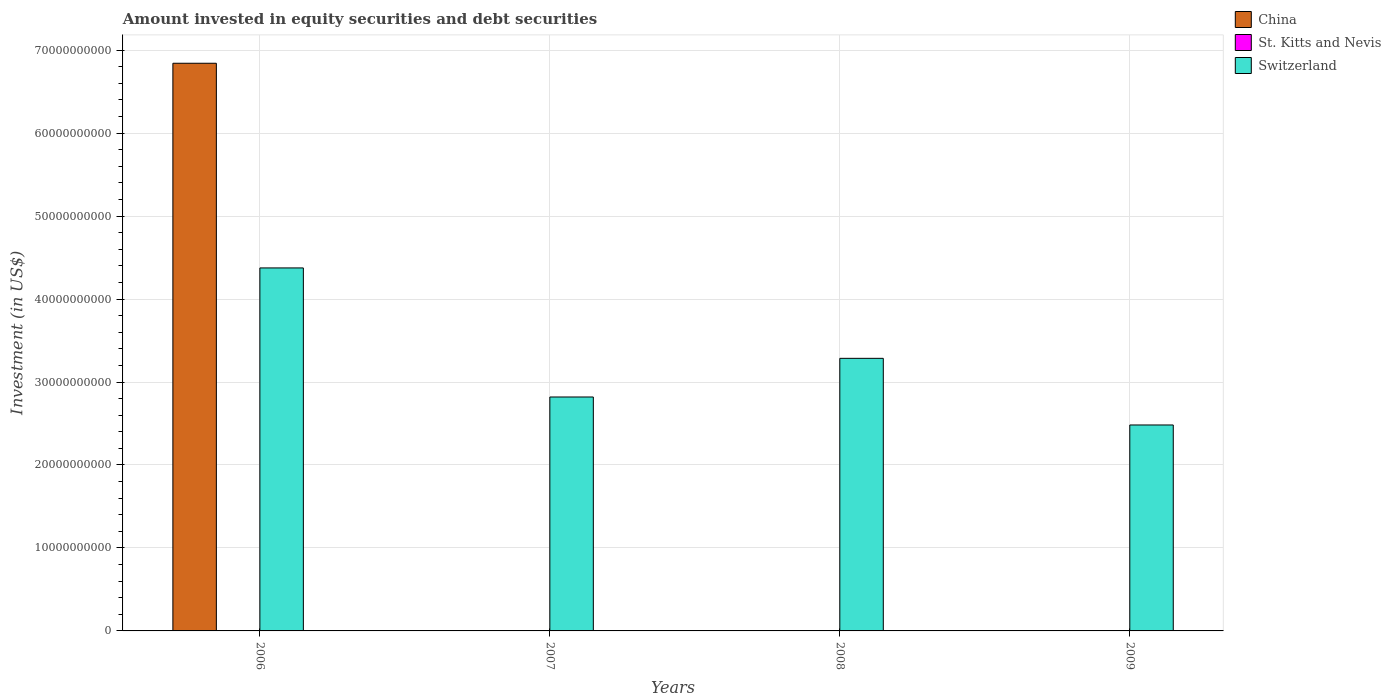How many different coloured bars are there?
Keep it short and to the point. 3. In how many cases, is the number of bars for a given year not equal to the number of legend labels?
Your answer should be very brief. 3. Across all years, what is the maximum amount invested in equity securities and debt securities in China?
Provide a succinct answer. 6.84e+1. In which year was the amount invested in equity securities and debt securities in Switzerland maximum?
Ensure brevity in your answer.  2006. What is the total amount invested in equity securities and debt securities in China in the graph?
Ensure brevity in your answer.  6.84e+1. What is the difference between the amount invested in equity securities and debt securities in Switzerland in 2006 and that in 2008?
Your answer should be compact. 1.09e+1. What is the difference between the amount invested in equity securities and debt securities in St. Kitts and Nevis in 2007 and the amount invested in equity securities and debt securities in China in 2009?
Your answer should be compact. 1.30e+07. What is the average amount invested in equity securities and debt securities in China per year?
Offer a terse response. 1.71e+1. In the year 2006, what is the difference between the amount invested in equity securities and debt securities in St. Kitts and Nevis and amount invested in equity securities and debt securities in Switzerland?
Provide a succinct answer. -4.37e+1. In how many years, is the amount invested in equity securities and debt securities in St. Kitts and Nevis greater than 68000000000 US$?
Ensure brevity in your answer.  0. What is the ratio of the amount invested in equity securities and debt securities in Switzerland in 2006 to that in 2008?
Provide a succinct answer. 1.33. Is the amount invested in equity securities and debt securities in Switzerland in 2008 less than that in 2009?
Offer a terse response. No. Is the difference between the amount invested in equity securities and debt securities in St. Kitts and Nevis in 2006 and 2009 greater than the difference between the amount invested in equity securities and debt securities in Switzerland in 2006 and 2009?
Offer a terse response. No. What is the difference between the highest and the second highest amount invested in equity securities and debt securities in St. Kitts and Nevis?
Keep it short and to the point. 7.99e+06. What is the difference between the highest and the lowest amount invested in equity securities and debt securities in St. Kitts and Nevis?
Provide a short and direct response. 2.10e+07. How many years are there in the graph?
Keep it short and to the point. 4. What is the difference between two consecutive major ticks on the Y-axis?
Provide a succinct answer. 1.00e+1. Are the values on the major ticks of Y-axis written in scientific E-notation?
Make the answer very short. No. Does the graph contain grids?
Your response must be concise. Yes. Where does the legend appear in the graph?
Give a very brief answer. Top right. How many legend labels are there?
Keep it short and to the point. 3. How are the legend labels stacked?
Provide a succinct answer. Vertical. What is the title of the graph?
Your response must be concise. Amount invested in equity securities and debt securities. Does "High income" appear as one of the legend labels in the graph?
Ensure brevity in your answer.  No. What is the label or title of the Y-axis?
Give a very brief answer. Investment (in US$). What is the Investment (in US$) of China in 2006?
Offer a very short reply. 6.84e+1. What is the Investment (in US$) of St. Kitts and Nevis in 2006?
Ensure brevity in your answer.  2.10e+07. What is the Investment (in US$) of Switzerland in 2006?
Your answer should be very brief. 4.37e+1. What is the Investment (in US$) of China in 2007?
Keep it short and to the point. 0. What is the Investment (in US$) of St. Kitts and Nevis in 2007?
Offer a terse response. 1.30e+07. What is the Investment (in US$) of Switzerland in 2007?
Your answer should be very brief. 2.82e+1. What is the Investment (in US$) of China in 2008?
Make the answer very short. 0. What is the Investment (in US$) of St. Kitts and Nevis in 2008?
Give a very brief answer. 0. What is the Investment (in US$) of Switzerland in 2008?
Provide a short and direct response. 3.29e+1. What is the Investment (in US$) of China in 2009?
Offer a terse response. 0. What is the Investment (in US$) in St. Kitts and Nevis in 2009?
Your answer should be compact. 1.12e+07. What is the Investment (in US$) in Switzerland in 2009?
Your answer should be very brief. 2.48e+1. Across all years, what is the maximum Investment (in US$) of China?
Your response must be concise. 6.84e+1. Across all years, what is the maximum Investment (in US$) of St. Kitts and Nevis?
Your response must be concise. 2.10e+07. Across all years, what is the maximum Investment (in US$) in Switzerland?
Provide a succinct answer. 4.37e+1. Across all years, what is the minimum Investment (in US$) in St. Kitts and Nevis?
Offer a very short reply. 0. Across all years, what is the minimum Investment (in US$) in Switzerland?
Offer a very short reply. 2.48e+1. What is the total Investment (in US$) of China in the graph?
Keep it short and to the point. 6.84e+1. What is the total Investment (in US$) in St. Kitts and Nevis in the graph?
Offer a terse response. 4.51e+07. What is the total Investment (in US$) in Switzerland in the graph?
Your answer should be compact. 1.30e+11. What is the difference between the Investment (in US$) in St. Kitts and Nevis in 2006 and that in 2007?
Ensure brevity in your answer.  7.99e+06. What is the difference between the Investment (in US$) in Switzerland in 2006 and that in 2007?
Provide a short and direct response. 1.56e+1. What is the difference between the Investment (in US$) in Switzerland in 2006 and that in 2008?
Keep it short and to the point. 1.09e+1. What is the difference between the Investment (in US$) of St. Kitts and Nevis in 2006 and that in 2009?
Provide a short and direct response. 9.81e+06. What is the difference between the Investment (in US$) in Switzerland in 2006 and that in 2009?
Your answer should be very brief. 1.89e+1. What is the difference between the Investment (in US$) in Switzerland in 2007 and that in 2008?
Your answer should be compact. -4.66e+09. What is the difference between the Investment (in US$) of St. Kitts and Nevis in 2007 and that in 2009?
Your response must be concise. 1.82e+06. What is the difference between the Investment (in US$) in Switzerland in 2007 and that in 2009?
Your answer should be very brief. 3.37e+09. What is the difference between the Investment (in US$) of Switzerland in 2008 and that in 2009?
Your answer should be very brief. 8.03e+09. What is the difference between the Investment (in US$) in China in 2006 and the Investment (in US$) in St. Kitts and Nevis in 2007?
Offer a very short reply. 6.84e+1. What is the difference between the Investment (in US$) in China in 2006 and the Investment (in US$) in Switzerland in 2007?
Keep it short and to the point. 4.02e+1. What is the difference between the Investment (in US$) in St. Kitts and Nevis in 2006 and the Investment (in US$) in Switzerland in 2007?
Make the answer very short. -2.82e+1. What is the difference between the Investment (in US$) in China in 2006 and the Investment (in US$) in Switzerland in 2008?
Offer a very short reply. 3.56e+1. What is the difference between the Investment (in US$) in St. Kitts and Nevis in 2006 and the Investment (in US$) in Switzerland in 2008?
Your answer should be very brief. -3.28e+1. What is the difference between the Investment (in US$) of China in 2006 and the Investment (in US$) of St. Kitts and Nevis in 2009?
Provide a short and direct response. 6.84e+1. What is the difference between the Investment (in US$) of China in 2006 and the Investment (in US$) of Switzerland in 2009?
Your response must be concise. 4.36e+1. What is the difference between the Investment (in US$) in St. Kitts and Nevis in 2006 and the Investment (in US$) in Switzerland in 2009?
Ensure brevity in your answer.  -2.48e+1. What is the difference between the Investment (in US$) of St. Kitts and Nevis in 2007 and the Investment (in US$) of Switzerland in 2008?
Make the answer very short. -3.28e+1. What is the difference between the Investment (in US$) in St. Kitts and Nevis in 2007 and the Investment (in US$) in Switzerland in 2009?
Give a very brief answer. -2.48e+1. What is the average Investment (in US$) of China per year?
Provide a short and direct response. 1.71e+1. What is the average Investment (in US$) of St. Kitts and Nevis per year?
Offer a terse response. 1.13e+07. What is the average Investment (in US$) of Switzerland per year?
Your answer should be very brief. 3.24e+1. In the year 2006, what is the difference between the Investment (in US$) of China and Investment (in US$) of St. Kitts and Nevis?
Provide a short and direct response. 6.84e+1. In the year 2006, what is the difference between the Investment (in US$) of China and Investment (in US$) of Switzerland?
Your answer should be very brief. 2.47e+1. In the year 2006, what is the difference between the Investment (in US$) of St. Kitts and Nevis and Investment (in US$) of Switzerland?
Offer a very short reply. -4.37e+1. In the year 2007, what is the difference between the Investment (in US$) in St. Kitts and Nevis and Investment (in US$) in Switzerland?
Give a very brief answer. -2.82e+1. In the year 2009, what is the difference between the Investment (in US$) in St. Kitts and Nevis and Investment (in US$) in Switzerland?
Your answer should be very brief. -2.48e+1. What is the ratio of the Investment (in US$) in St. Kitts and Nevis in 2006 to that in 2007?
Give a very brief answer. 1.62. What is the ratio of the Investment (in US$) of Switzerland in 2006 to that in 2007?
Keep it short and to the point. 1.55. What is the ratio of the Investment (in US$) of Switzerland in 2006 to that in 2008?
Your answer should be very brief. 1.33. What is the ratio of the Investment (in US$) in St. Kitts and Nevis in 2006 to that in 2009?
Provide a succinct answer. 1.88. What is the ratio of the Investment (in US$) of Switzerland in 2006 to that in 2009?
Offer a terse response. 1.76. What is the ratio of the Investment (in US$) of Switzerland in 2007 to that in 2008?
Ensure brevity in your answer.  0.86. What is the ratio of the Investment (in US$) in St. Kitts and Nevis in 2007 to that in 2009?
Your answer should be compact. 1.16. What is the ratio of the Investment (in US$) of Switzerland in 2007 to that in 2009?
Ensure brevity in your answer.  1.14. What is the ratio of the Investment (in US$) of Switzerland in 2008 to that in 2009?
Make the answer very short. 1.32. What is the difference between the highest and the second highest Investment (in US$) of St. Kitts and Nevis?
Provide a short and direct response. 7.99e+06. What is the difference between the highest and the second highest Investment (in US$) of Switzerland?
Your answer should be very brief. 1.09e+1. What is the difference between the highest and the lowest Investment (in US$) of China?
Offer a very short reply. 6.84e+1. What is the difference between the highest and the lowest Investment (in US$) in St. Kitts and Nevis?
Your answer should be compact. 2.10e+07. What is the difference between the highest and the lowest Investment (in US$) of Switzerland?
Give a very brief answer. 1.89e+1. 